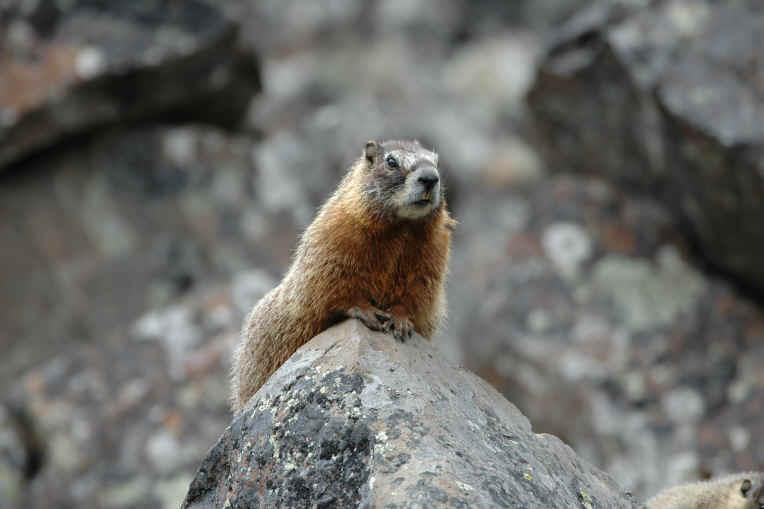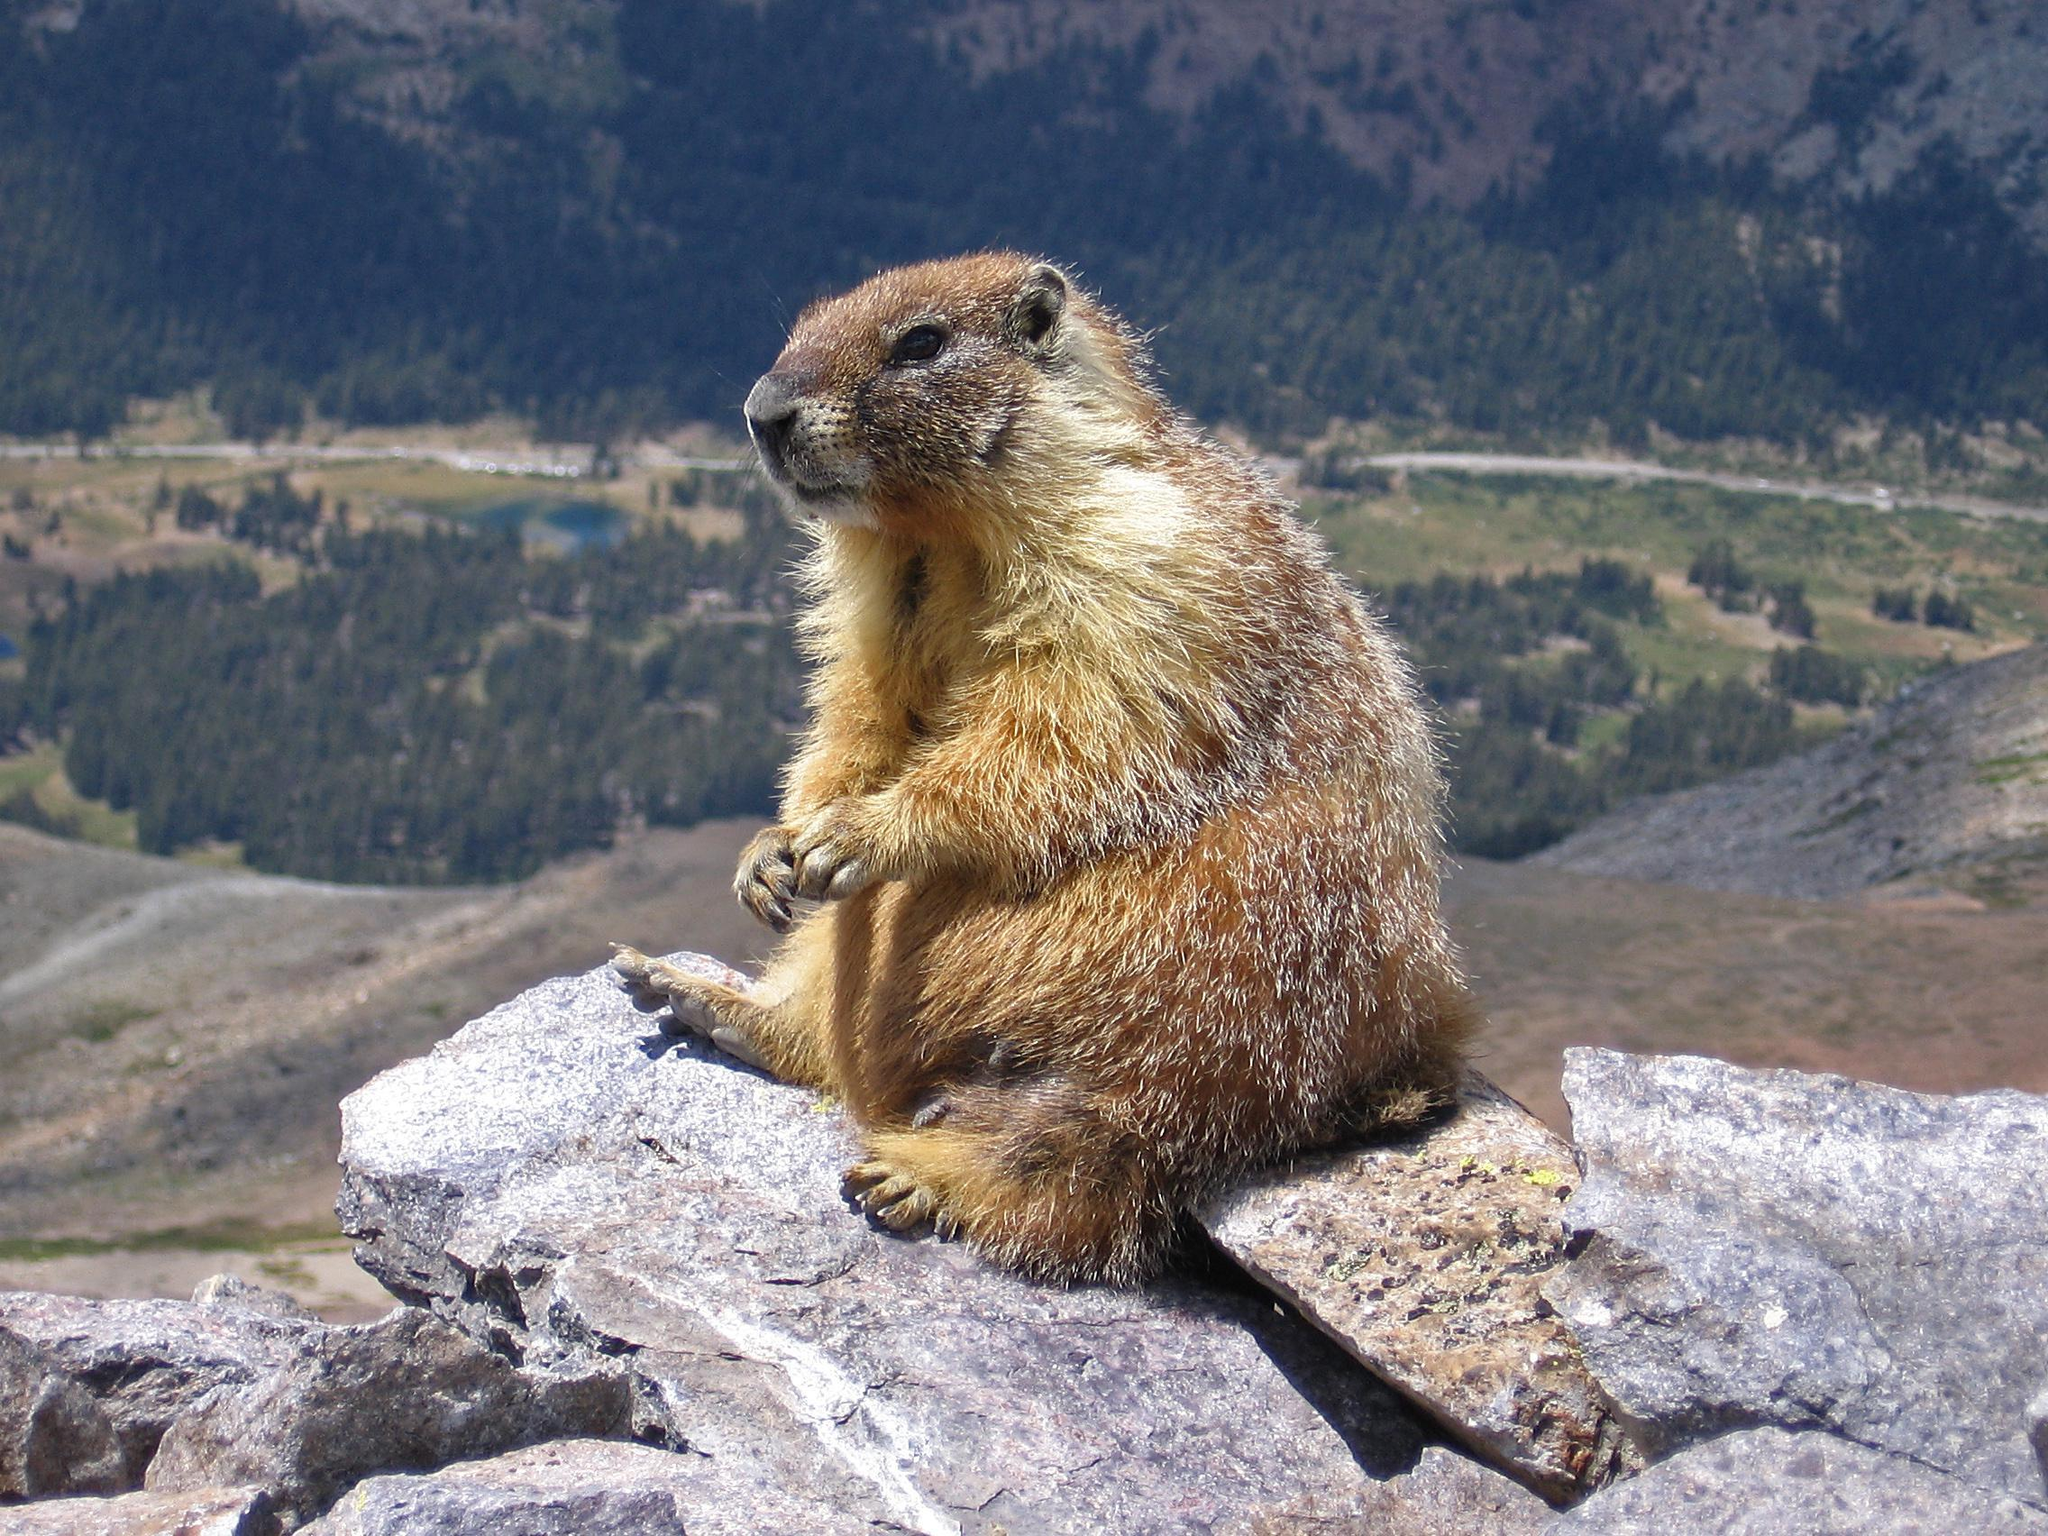The first image is the image on the left, the second image is the image on the right. Assess this claim about the two images: "The left and right image contains a total of two groundhogs facing the same direction.". Correct or not? Answer yes or no. No. The first image is the image on the left, the second image is the image on the right. Examine the images to the left and right. Is the description "At least one of the small mammals is looking directly to the right, alone in it's own image." accurate? Answer yes or no. No. 